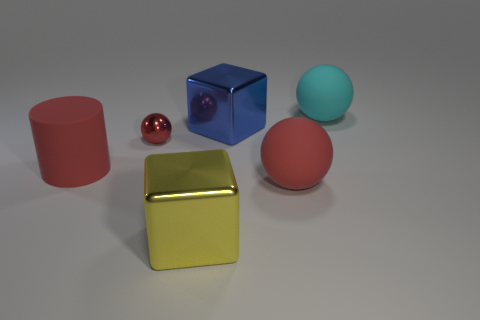How many things are red things that are to the left of the big yellow object or large shiny blocks in front of the small ball? In the image, there is one red cylinder to the left of the big yellow cube. Additionally, if we consider 'large shiny blocks' to include the blue cube and the yellow cube, then there are two blocks in front of the small red sphere. So in total, there are three items that fit the criteria: one red cylinder and two shiny blocks. 